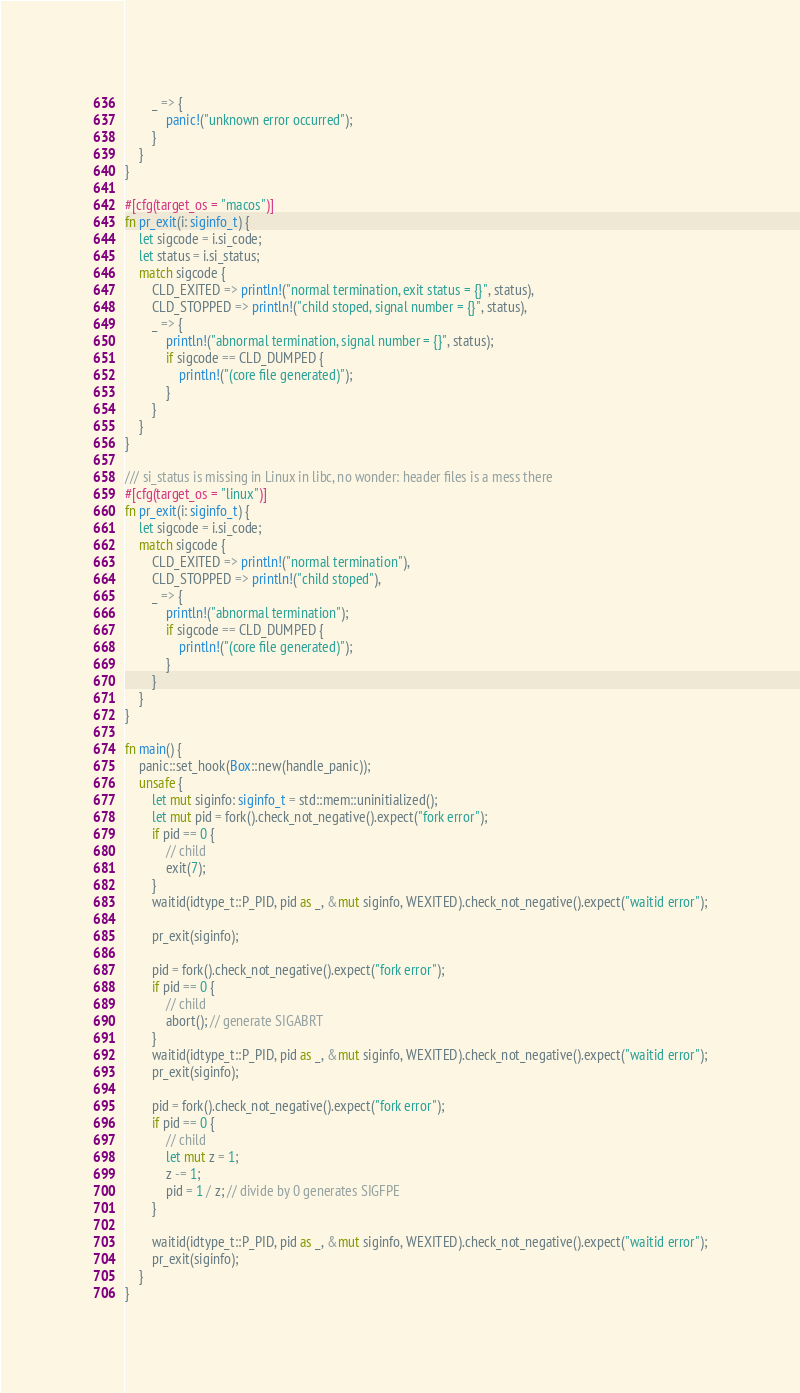Convert code to text. <code><loc_0><loc_0><loc_500><loc_500><_Rust_>        _ => {
            panic!("unknown error occurred");
        }
    }
}

#[cfg(target_os = "macos")]
fn pr_exit(i: siginfo_t) {
    let sigcode = i.si_code;
    let status = i.si_status;
    match sigcode {
        CLD_EXITED => println!("normal termination, exit status = {}", status),
        CLD_STOPPED => println!("child stoped, signal number = {}", status),
        _ => {
            println!("abnormal termination, signal number = {}", status);
            if sigcode == CLD_DUMPED {
                println!("(core file generated)");
            }
        }
    }
}

/// si_status is missing in Linux in libc, no wonder: header files is a mess there
#[cfg(target_os = "linux")]
fn pr_exit(i: siginfo_t) {
    let sigcode = i.si_code;
    match sigcode {
        CLD_EXITED => println!("normal termination"),
        CLD_STOPPED => println!("child stoped"),
        _ => {
            println!("abnormal termination");
            if sigcode == CLD_DUMPED {
                println!("(core file generated)");
            }
        }
    }
}

fn main() {
    panic::set_hook(Box::new(handle_panic));
    unsafe {
        let mut siginfo: siginfo_t = std::mem::uninitialized();
        let mut pid = fork().check_not_negative().expect("fork error");
        if pid == 0 {
            // child
            exit(7);
        }
        waitid(idtype_t::P_PID, pid as _, &mut siginfo, WEXITED).check_not_negative().expect("waitid error");

        pr_exit(siginfo);

        pid = fork().check_not_negative().expect("fork error");
        if pid == 0 {
            // child
            abort(); // generate SIGABRT
        }
        waitid(idtype_t::P_PID, pid as _, &mut siginfo, WEXITED).check_not_negative().expect("waitid error");
        pr_exit(siginfo);

        pid = fork().check_not_negative().expect("fork error");
        if pid == 0 {
            // child
            let mut z = 1;
            z -= 1;
            pid = 1 / z; // divide by 0 generates SIGFPE
        }

        waitid(idtype_t::P_PID, pid as _, &mut siginfo, WEXITED).check_not_negative().expect("waitid error");
        pr_exit(siginfo);
    }
}
</code> 